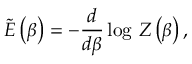<formula> <loc_0><loc_0><loc_500><loc_500>\widetilde { E } \left ( \beta \right ) = - \frac { d } { d \beta } \log \, Z \left ( \beta \right ) ,</formula> 